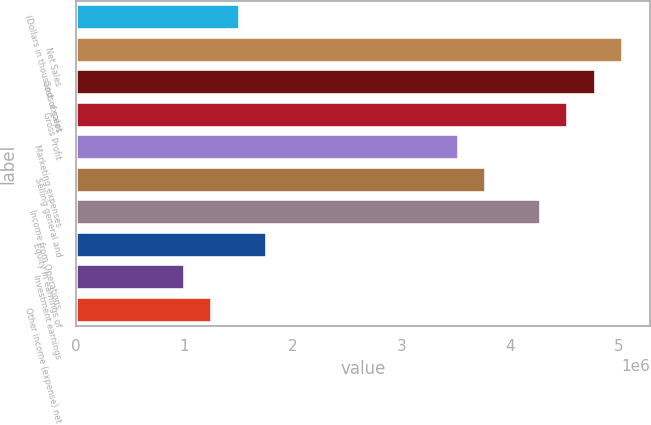Convert chart. <chart><loc_0><loc_0><loc_500><loc_500><bar_chart><fcel>(Dollars in thousands except<fcel>Net Sales<fcel>Cost of sales<fcel>Gross Profit<fcel>Marketing expenses<fcel>Selling general and<fcel>Income from Operations<fcel>Equity in earnings of<fcel>Investment earnings<fcel>Other income (expense) net<nl><fcel>1.51255e+06<fcel>5.04184e+06<fcel>4.78975e+06<fcel>4.53766e+06<fcel>3.52929e+06<fcel>3.78138e+06<fcel>4.28557e+06<fcel>1.76465e+06<fcel>1.00837e+06<fcel>1.26046e+06<nl></chart> 